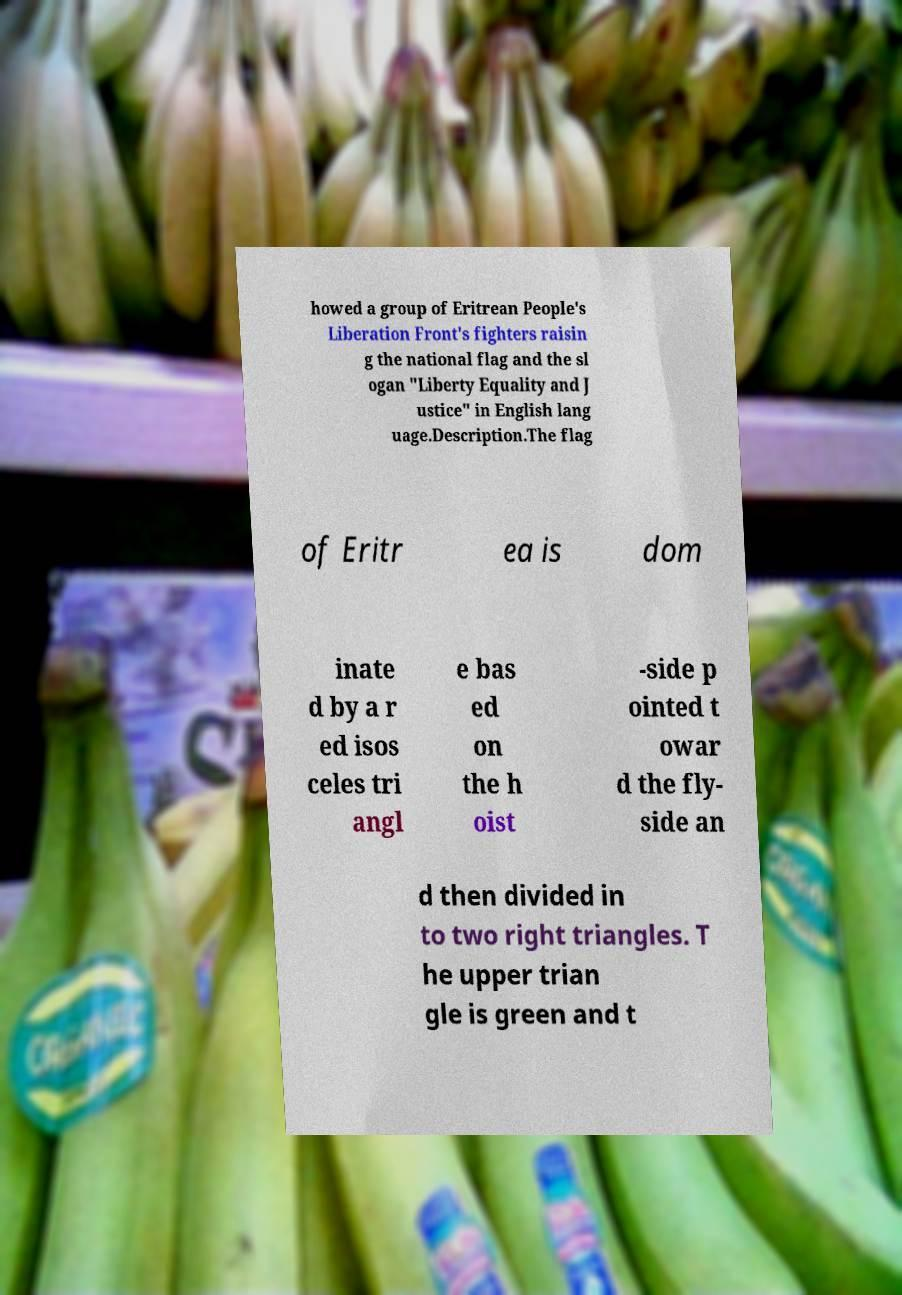Please identify and transcribe the text found in this image. howed a group of Eritrean People's Liberation Front's fighters raisin g the national flag and the sl ogan "Liberty Equality and J ustice" in English lang uage.Description.The flag of Eritr ea is dom inate d by a r ed isos celes tri angl e bas ed on the h oist -side p ointed t owar d the fly- side an d then divided in to two right triangles. T he upper trian gle is green and t 